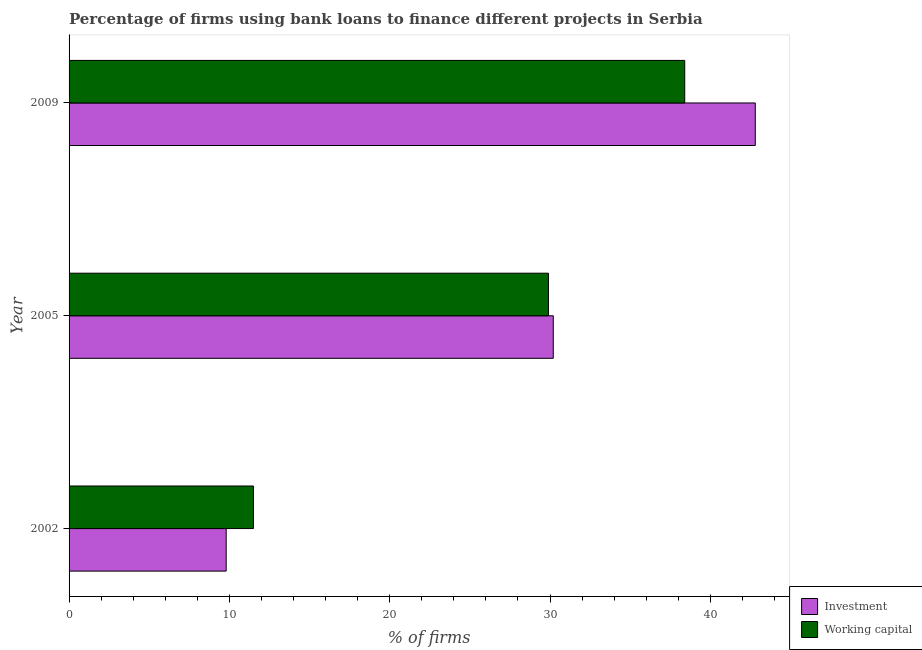How many groups of bars are there?
Ensure brevity in your answer.  3. How many bars are there on the 2nd tick from the top?
Provide a succinct answer. 2. How many bars are there on the 3rd tick from the bottom?
Make the answer very short. 2. In how many cases, is the number of bars for a given year not equal to the number of legend labels?
Provide a succinct answer. 0. What is the percentage of firms using banks to finance investment in 2005?
Ensure brevity in your answer.  30.2. Across all years, what is the maximum percentage of firms using banks to finance working capital?
Ensure brevity in your answer.  38.4. Across all years, what is the minimum percentage of firms using banks to finance investment?
Give a very brief answer. 9.8. In which year was the percentage of firms using banks to finance working capital maximum?
Your answer should be compact. 2009. In which year was the percentage of firms using banks to finance working capital minimum?
Your answer should be very brief. 2002. What is the total percentage of firms using banks to finance working capital in the graph?
Offer a terse response. 79.8. What is the difference between the percentage of firms using banks to finance investment in 2002 and that in 2005?
Your response must be concise. -20.4. What is the difference between the percentage of firms using banks to finance working capital in 2009 and the percentage of firms using banks to finance investment in 2002?
Your answer should be very brief. 28.6. What is the average percentage of firms using banks to finance working capital per year?
Your answer should be very brief. 26.6. In how many years, is the percentage of firms using banks to finance investment greater than 14 %?
Provide a short and direct response. 2. What is the ratio of the percentage of firms using banks to finance working capital in 2002 to that in 2009?
Ensure brevity in your answer.  0.3. Is the percentage of firms using banks to finance investment in 2002 less than that in 2005?
Give a very brief answer. Yes. What is the difference between the highest and the second highest percentage of firms using banks to finance working capital?
Your answer should be compact. 8.5. Is the sum of the percentage of firms using banks to finance investment in 2002 and 2009 greater than the maximum percentage of firms using banks to finance working capital across all years?
Give a very brief answer. Yes. What does the 1st bar from the top in 2005 represents?
Make the answer very short. Working capital. What does the 1st bar from the bottom in 2005 represents?
Ensure brevity in your answer.  Investment. Are all the bars in the graph horizontal?
Provide a succinct answer. Yes. What is the difference between two consecutive major ticks on the X-axis?
Keep it short and to the point. 10. Does the graph contain any zero values?
Offer a very short reply. No. Does the graph contain grids?
Your answer should be very brief. No. Where does the legend appear in the graph?
Keep it short and to the point. Bottom right. How are the legend labels stacked?
Your answer should be compact. Vertical. What is the title of the graph?
Ensure brevity in your answer.  Percentage of firms using bank loans to finance different projects in Serbia. What is the label or title of the X-axis?
Provide a succinct answer. % of firms. What is the % of firms of Investment in 2002?
Make the answer very short. 9.8. What is the % of firms in Investment in 2005?
Ensure brevity in your answer.  30.2. What is the % of firms of Working capital in 2005?
Provide a short and direct response. 29.9. What is the % of firms of Investment in 2009?
Offer a terse response. 42.8. What is the % of firms in Working capital in 2009?
Your response must be concise. 38.4. Across all years, what is the maximum % of firms of Investment?
Your response must be concise. 42.8. Across all years, what is the maximum % of firms in Working capital?
Provide a short and direct response. 38.4. Across all years, what is the minimum % of firms in Investment?
Offer a very short reply. 9.8. What is the total % of firms in Investment in the graph?
Keep it short and to the point. 82.8. What is the total % of firms of Working capital in the graph?
Offer a very short reply. 79.8. What is the difference between the % of firms in Investment in 2002 and that in 2005?
Ensure brevity in your answer.  -20.4. What is the difference between the % of firms of Working capital in 2002 and that in 2005?
Offer a terse response. -18.4. What is the difference between the % of firms of Investment in 2002 and that in 2009?
Provide a succinct answer. -33. What is the difference between the % of firms in Working capital in 2002 and that in 2009?
Keep it short and to the point. -26.9. What is the difference between the % of firms in Working capital in 2005 and that in 2009?
Provide a short and direct response. -8.5. What is the difference between the % of firms of Investment in 2002 and the % of firms of Working capital in 2005?
Ensure brevity in your answer.  -20.1. What is the difference between the % of firms of Investment in 2002 and the % of firms of Working capital in 2009?
Your response must be concise. -28.6. What is the difference between the % of firms in Investment in 2005 and the % of firms in Working capital in 2009?
Keep it short and to the point. -8.2. What is the average % of firms of Investment per year?
Your response must be concise. 27.6. What is the average % of firms of Working capital per year?
Provide a succinct answer. 26.6. In the year 2002, what is the difference between the % of firms of Investment and % of firms of Working capital?
Offer a terse response. -1.7. In the year 2005, what is the difference between the % of firms in Investment and % of firms in Working capital?
Your answer should be very brief. 0.3. What is the ratio of the % of firms of Investment in 2002 to that in 2005?
Your response must be concise. 0.32. What is the ratio of the % of firms of Working capital in 2002 to that in 2005?
Give a very brief answer. 0.38. What is the ratio of the % of firms in Investment in 2002 to that in 2009?
Keep it short and to the point. 0.23. What is the ratio of the % of firms of Working capital in 2002 to that in 2009?
Offer a terse response. 0.3. What is the ratio of the % of firms of Investment in 2005 to that in 2009?
Offer a very short reply. 0.71. What is the ratio of the % of firms of Working capital in 2005 to that in 2009?
Your response must be concise. 0.78. What is the difference between the highest and the second highest % of firms in Investment?
Your response must be concise. 12.6. What is the difference between the highest and the lowest % of firms in Investment?
Offer a very short reply. 33. What is the difference between the highest and the lowest % of firms of Working capital?
Your answer should be compact. 26.9. 